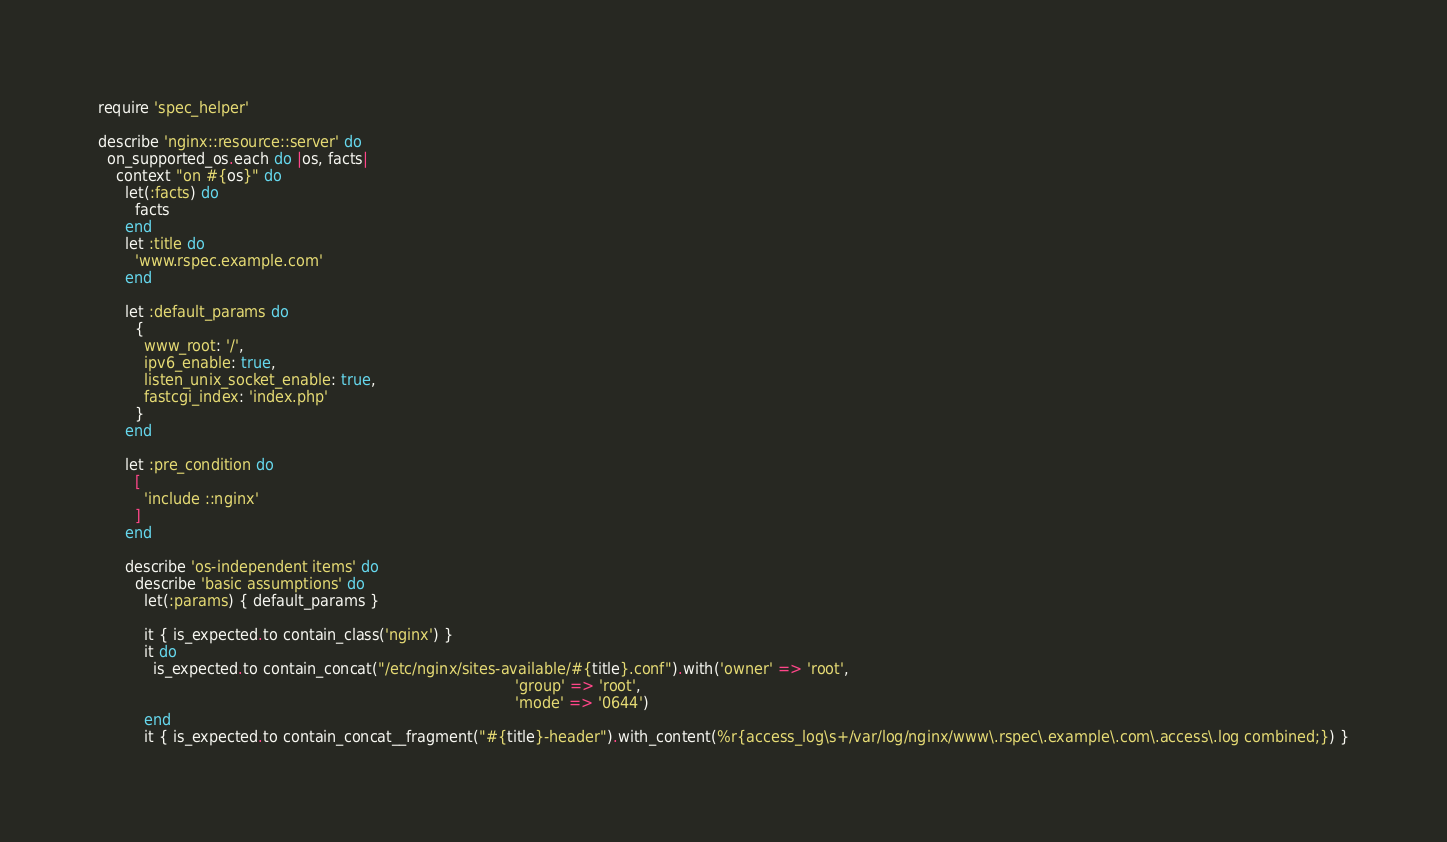<code> <loc_0><loc_0><loc_500><loc_500><_Ruby_>require 'spec_helper'

describe 'nginx::resource::server' do
  on_supported_os.each do |os, facts|
    context "on #{os}" do
      let(:facts) do
        facts
      end
      let :title do
        'www.rspec.example.com'
      end

      let :default_params do
        {
          www_root: '/',
          ipv6_enable: true,
          listen_unix_socket_enable: true,
          fastcgi_index: 'index.php'
        }
      end

      let :pre_condition do
        [
          'include ::nginx'
        ]
      end

      describe 'os-independent items' do
        describe 'basic assumptions' do
          let(:params) { default_params }

          it { is_expected.to contain_class('nginx') }
          it do
            is_expected.to contain_concat("/etc/nginx/sites-available/#{title}.conf").with('owner' => 'root',
                                                                                           'group' => 'root',
                                                                                           'mode' => '0644')
          end
          it { is_expected.to contain_concat__fragment("#{title}-header").with_content(%r{access_log\s+/var/log/nginx/www\.rspec\.example\.com\.access\.log combined;}) }</code> 